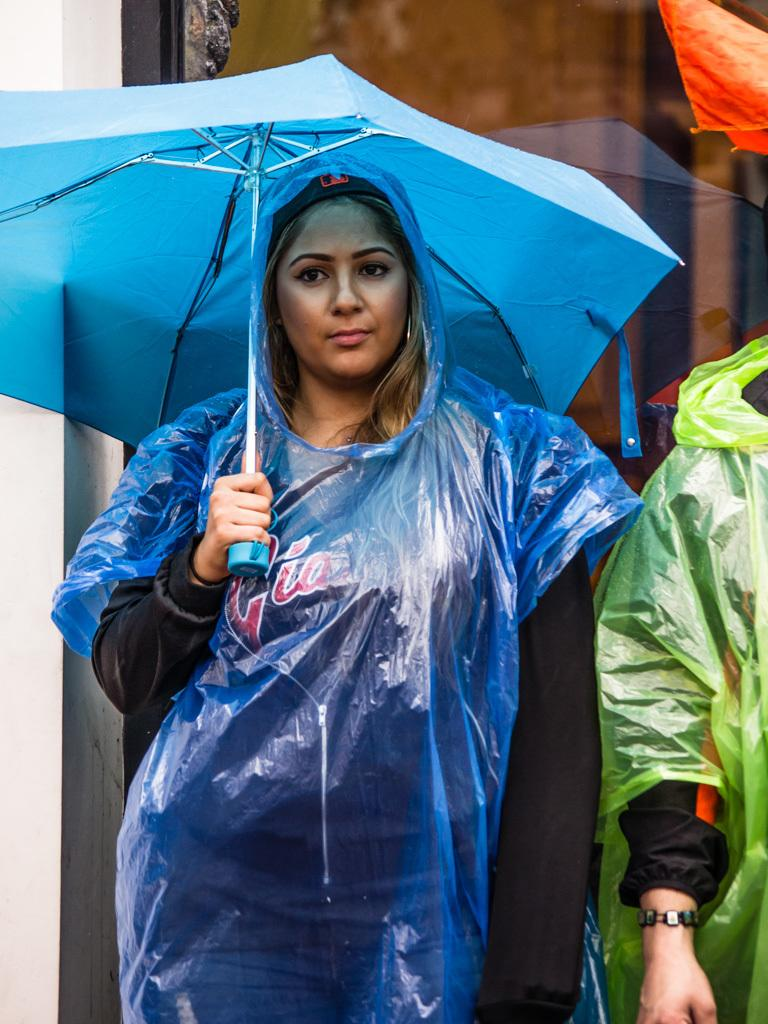Who is present in the image? There is a woman and another person in the image. What is the woman wearing in the image? The woman is wearing a raincoat in the image. What is the woman holding in the image? The woman is holding an umbrella in the image. What is the other person wearing in the image? The other person is also wearing a raincoat in the image. What flavor of kitty can be seen in the image? There is no kitty present in the image, so it is not possible to determine its flavor. What type of cow is visible in the image? There is no cow present in the image. 